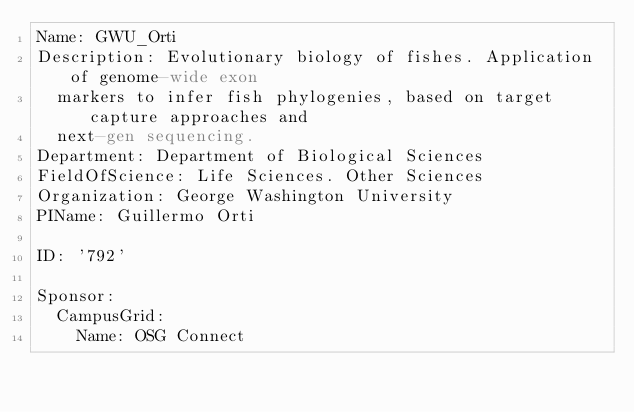<code> <loc_0><loc_0><loc_500><loc_500><_YAML_>Name: GWU_Orti
Description: Evolutionary biology of fishes. Application of genome-wide exon
  markers to infer fish phylogenies, based on target capture approaches and
  next-gen sequencing.
Department: Department of Biological Sciences
FieldOfScience: Life Sciences. Other Sciences
Organization: George Washington University
PIName: Guillermo Orti

ID: '792'

Sponsor:
  CampusGrid:
    Name: OSG Connect
</code> 